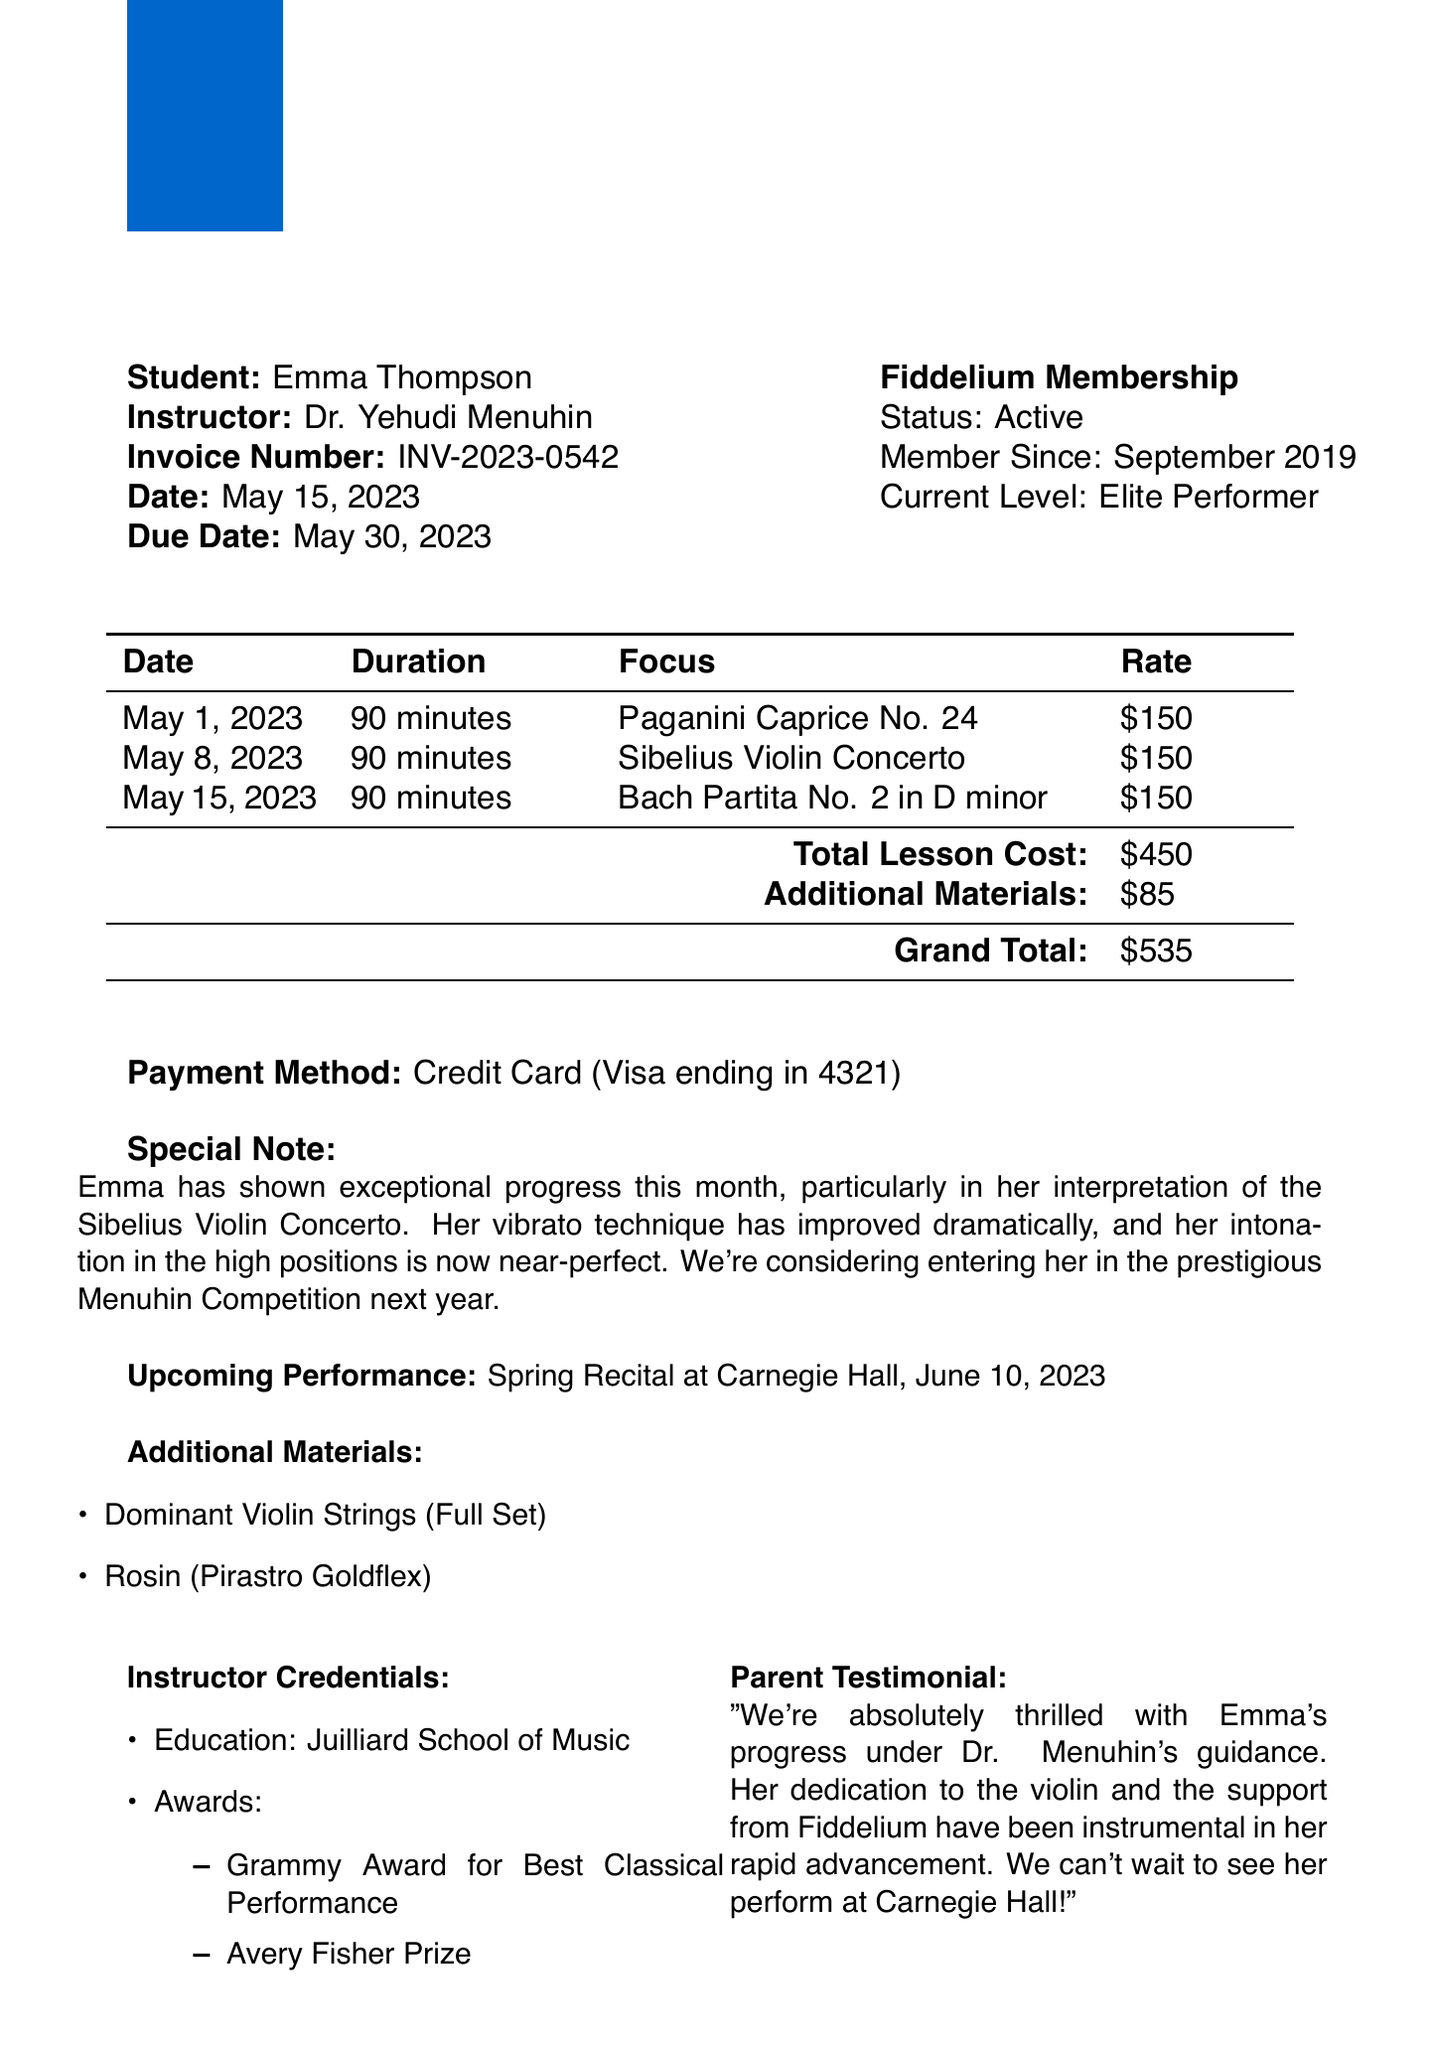What is the invoice number? The invoice number is clearly stated in the document as a unique identifier for the transaction.
Answer: INV-2023-0542 Who is the instructor? The document specifies the name of the instructor responsible for Emma's lessons.
Answer: Dr. Yehudi Menuhin What is the total amount due? The total amount due is closely detailed in the financial section of the document as the sum of lesson costs and additional materials.
Answer: $535 What upcoming performance is mentioned? The document outlines an upcoming event where Emma is scheduled to perform, highlighting her participation.
Answer: Spring Recital at Carnegie Hall, June 10, 2023 How long was each lesson? The duration of lessons is uniformly mentioned in the document, indicating the time spent on each session.
Answer: 90 minutes Why is Emma's progress highlighted? The special note in the document points out the remarkable improvements Emma has made over the month, particularly in her technique.
Answer: Exceptional progress When is the payment due date? The due date for payment is specified in the document, which provides a deadline for completing the transaction.
Answer: May 30, 2023 What additional materials were purchased? The document lists specific items that were acquired alongside the lessons, providing insight into what is needed for her training.
Answer: Dominant Violin Strings (Full Set), Rosin (Pirastro Goldflex) What is Emma's current level of membership at Fiddelium? The membership section of the document describes Emma's status and her level within the organization.
Answer: Elite Performer 